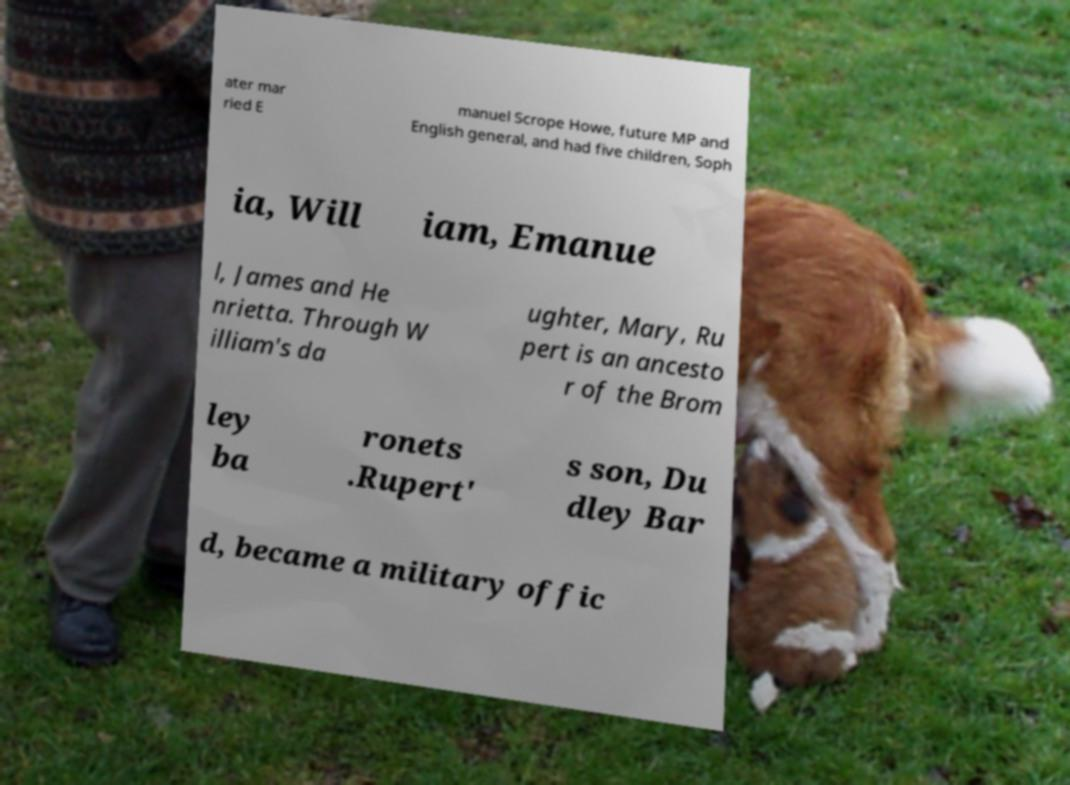What messages or text are displayed in this image? I need them in a readable, typed format. ater mar ried E manuel Scrope Howe, future MP and English general, and had five children, Soph ia, Will iam, Emanue l, James and He nrietta. Through W illiam's da ughter, Mary, Ru pert is an ancesto r of the Brom ley ba ronets .Rupert' s son, Du dley Bar d, became a military offic 